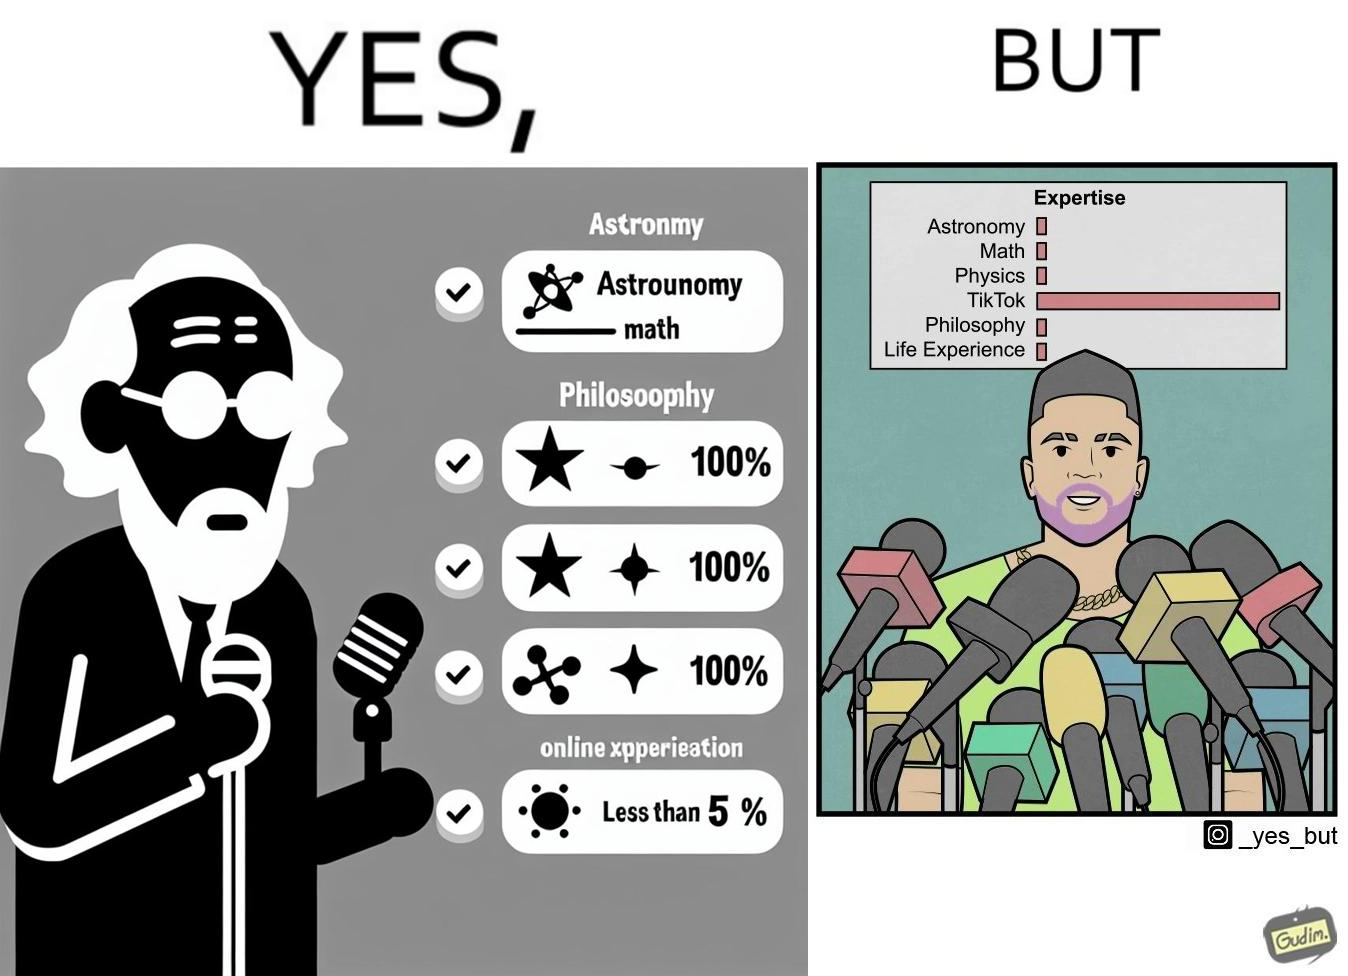Why is this image considered satirical? The image is satirical beacause it shows that people with more tiktok expertise are treated more importantly than the ones who are expert in all the other areas but tiktok. Here, the number of microphones a man speaks into is indicative of his importance. 